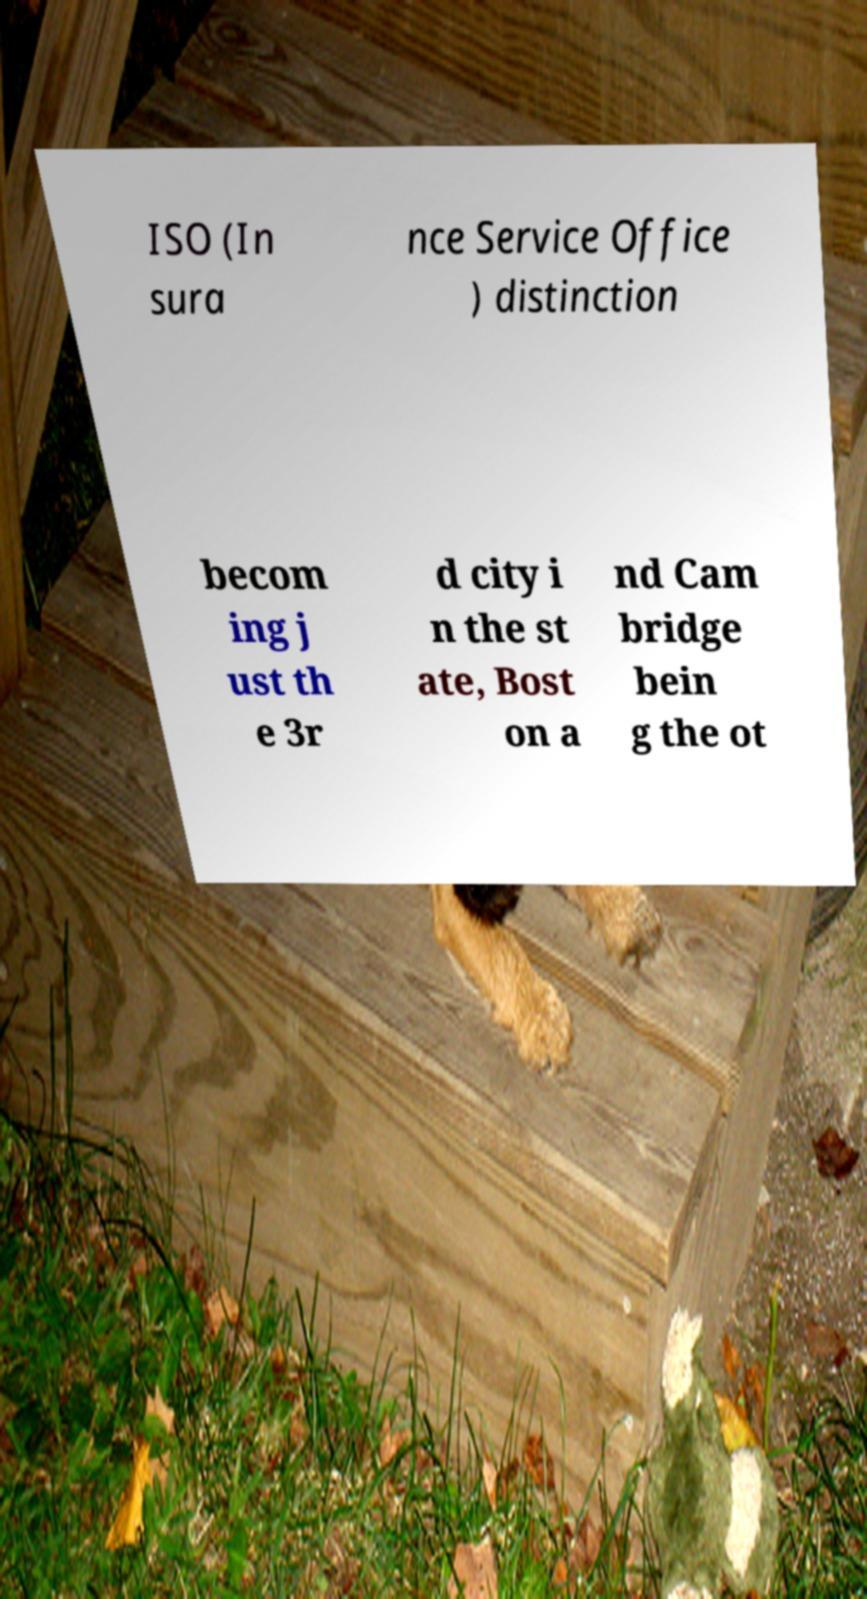Could you assist in decoding the text presented in this image and type it out clearly? ISO (In sura nce Service Office ) distinction becom ing j ust th e 3r d city i n the st ate, Bost on a nd Cam bridge bein g the ot 